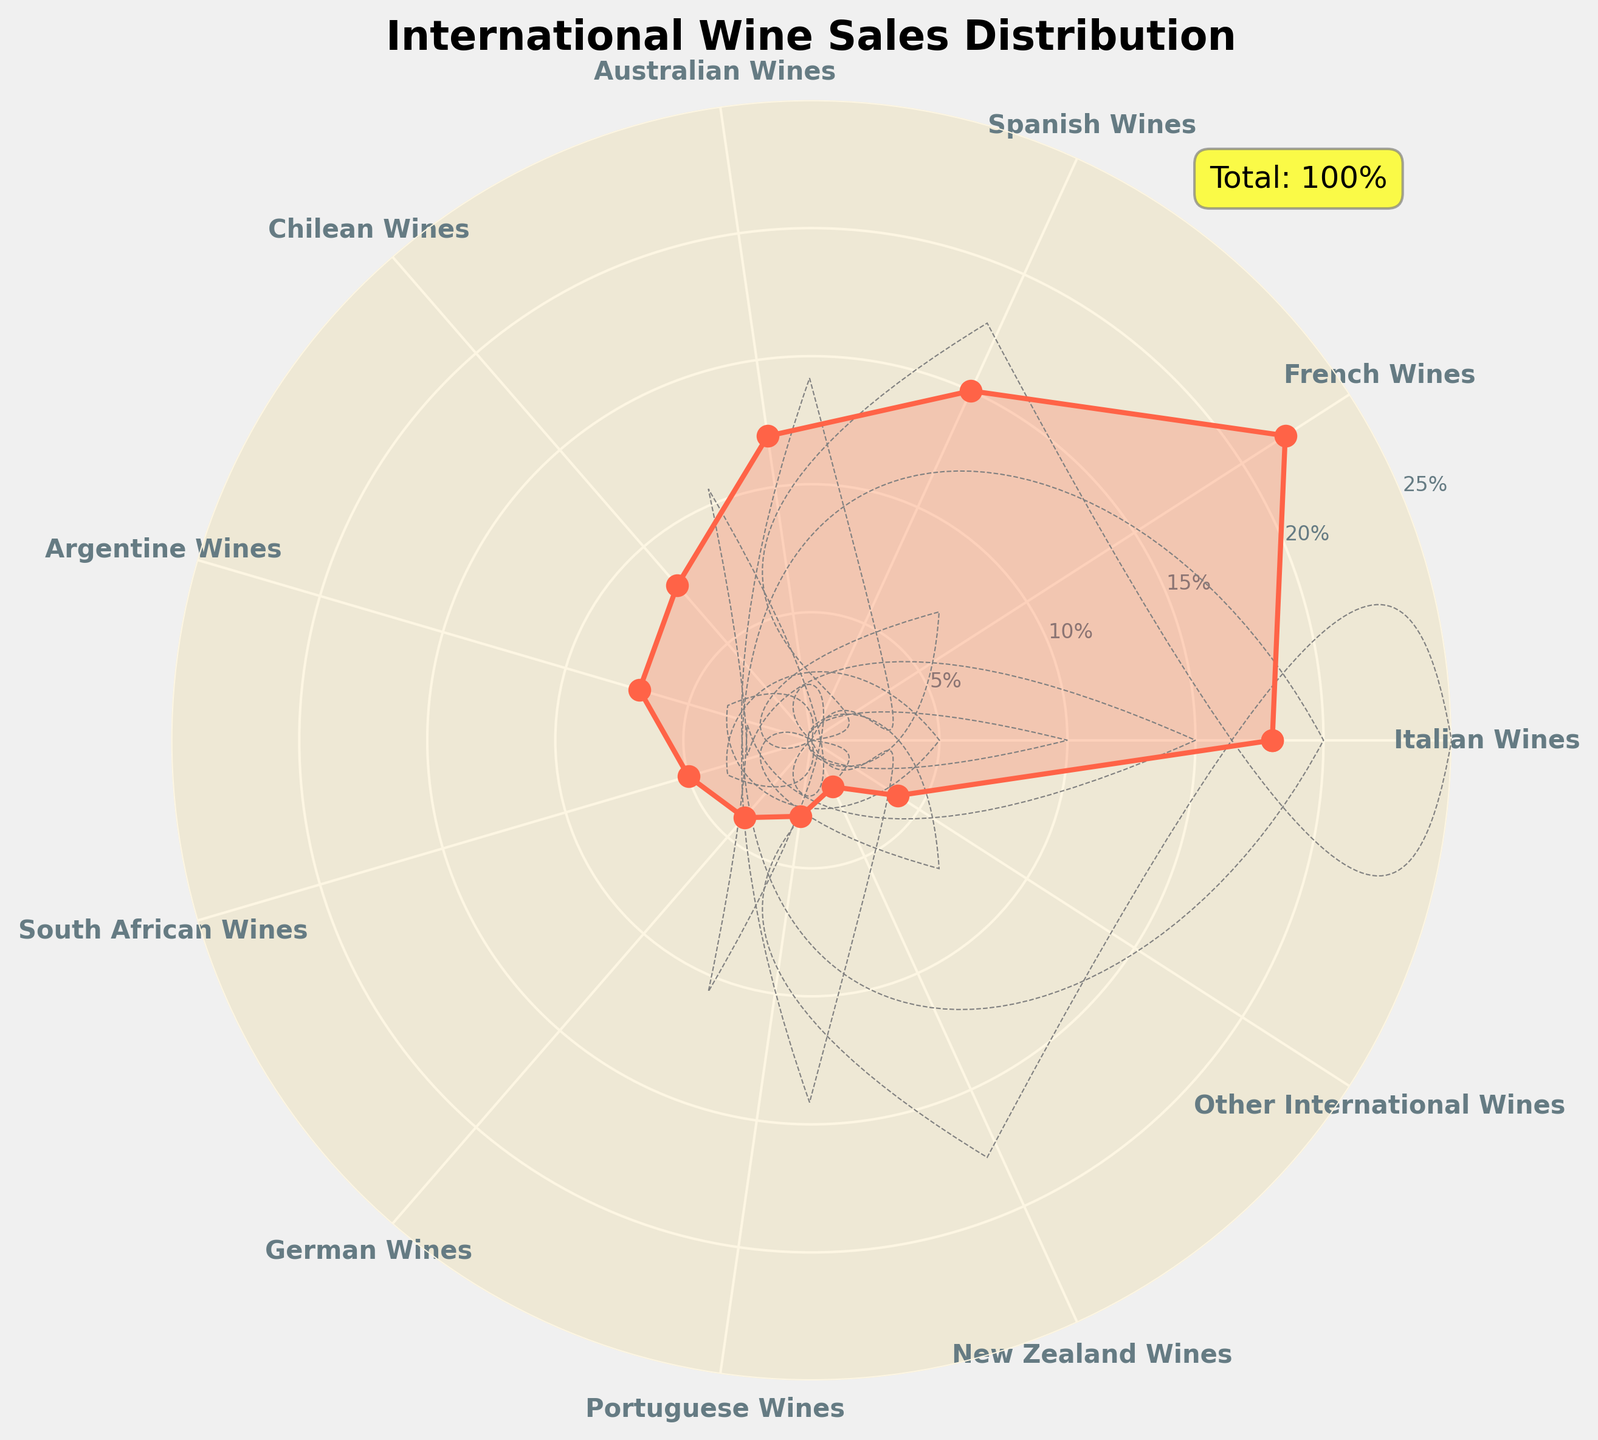What is the title of the figure? The title is located at the top center of the figure; it reads "International Wine Sales Distribution."
Answer: International Wine Sales Distribution What is the percentage of sales from French Wines? The percentage for French Wines appears at its corresponding angle on the circular plot where the label "French Wines" is located, with a value marked on the y-axis as 22%.
Answer: 22% How many categories of international wines are represented in the figure? The number of categories is indicated by the number of distinct segments or labels around the circular plot; there are 11 categories listed.
Answer: 11 Which country's wines have the lowest percentage of sales, and what is that percentage? By comparing the labels and their corresponding percentages on the circular plot, New Zealand Wines have the smallest sector with a percentage marked as 2%.
Answer: New Zealand Wines, 2% What's the combined percentage of sales for wines from Italy and Spain? Identify the percentages for Italian Wines (18%) and Spanish Wines (15%) from the plot. Sum these values: 18% + 15% = 33%.
Answer: 33% Which three countries' wines have the highest percentages of sales, and what are those percentages? The highest percentages can be observed directly from the chart: French Wines (22%), Italian Wines (18%), and Spanish Wines (15%).
Answer: French Wines (22%), Italian Wines (18%), Spanish Wines (15%) Is the percentage of sales from Australian Wines greater than that of Chilean Wines? By how much? Compare the two percentages directly from the chart: Australian Wines (12%) and Chilean Wines (8%). Calculate the difference: 12% - 8% = 4%.
Answer: Yes, by 4% What is the average percentage of sales from all the international wines? Sum all the percentages from the plot and divide by the number of categories. Total = 18% + 22% + 15% + 12% + 8% + 7% + 5% + 4% + 3% + 2% + 4% = 100%. Divide by 11: 100% / 11 ≈ 9.09%.
Answer: 9.09% What additional information is provided in the annotation box on the figure? The annotation box in the plot mentions "Total: 100%," indicating the sum of all categories' percentages.
Answer: Total: 100% 